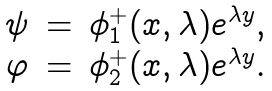<formula> <loc_0><loc_0><loc_500><loc_500>\begin{array} { c c c } \psi & = & \phi ^ { + } _ { 1 } ( x , \lambda ) e ^ { \lambda y } , \\ \varphi & = & \phi ^ { + } _ { 2 } ( x , \lambda ) e ^ { \lambda y } . \end{array}</formula> 